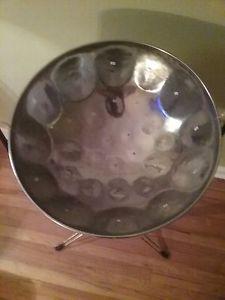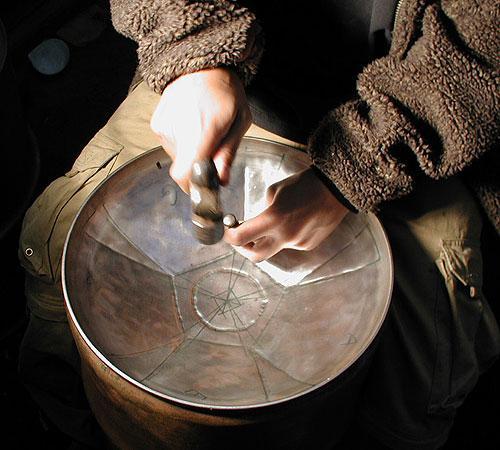The first image is the image on the left, the second image is the image on the right. Considering the images on both sides, is "There are two drum stick laying in the middle of an inverted metal drum." valid? Answer yes or no. No. The first image is the image on the left, the second image is the image on the right. Considering the images on both sides, is "The right image shows the interior of a concave metal drum, with a pair of drumsticks in its bowl." valid? Answer yes or no. No. 